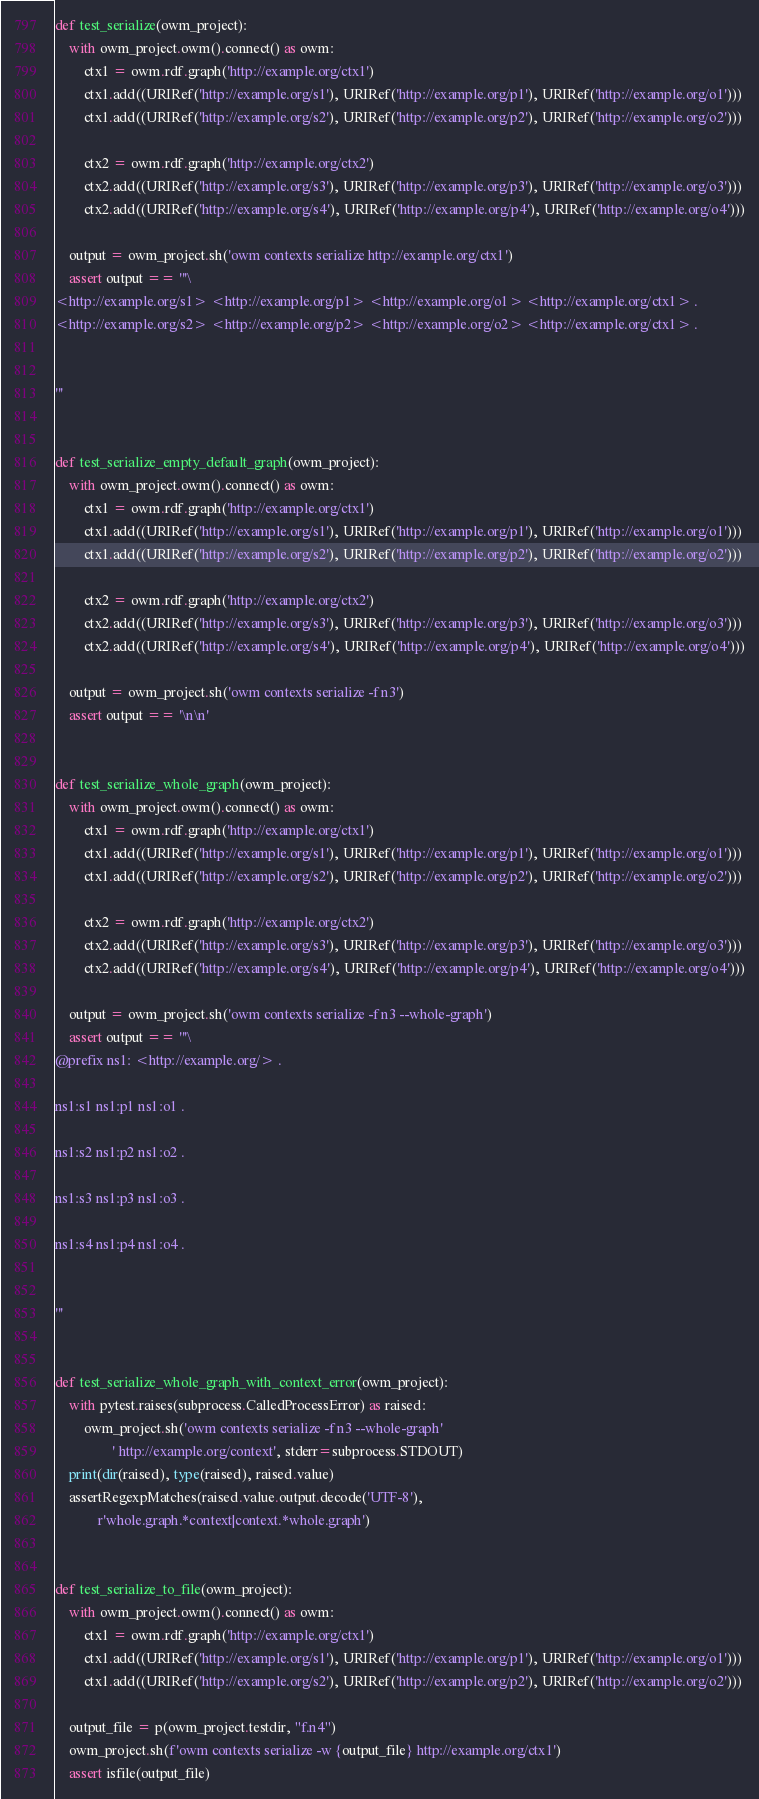Convert code to text. <code><loc_0><loc_0><loc_500><loc_500><_Python_>def test_serialize(owm_project):
    with owm_project.owm().connect() as owm:
        ctx1 = owm.rdf.graph('http://example.org/ctx1')
        ctx1.add((URIRef('http://example.org/s1'), URIRef('http://example.org/p1'), URIRef('http://example.org/o1')))
        ctx1.add((URIRef('http://example.org/s2'), URIRef('http://example.org/p2'), URIRef('http://example.org/o2')))

        ctx2 = owm.rdf.graph('http://example.org/ctx2')
        ctx2.add((URIRef('http://example.org/s3'), URIRef('http://example.org/p3'), URIRef('http://example.org/o3')))
        ctx2.add((URIRef('http://example.org/s4'), URIRef('http://example.org/p4'), URIRef('http://example.org/o4')))

    output = owm_project.sh('owm contexts serialize http://example.org/ctx1')
    assert output == '''\
<http://example.org/s1> <http://example.org/p1> <http://example.org/o1> <http://example.org/ctx1> .
<http://example.org/s2> <http://example.org/p2> <http://example.org/o2> <http://example.org/ctx1> .


'''


def test_serialize_empty_default_graph(owm_project):
    with owm_project.owm().connect() as owm:
        ctx1 = owm.rdf.graph('http://example.org/ctx1')
        ctx1.add((URIRef('http://example.org/s1'), URIRef('http://example.org/p1'), URIRef('http://example.org/o1')))
        ctx1.add((URIRef('http://example.org/s2'), URIRef('http://example.org/p2'), URIRef('http://example.org/o2')))

        ctx2 = owm.rdf.graph('http://example.org/ctx2')
        ctx2.add((URIRef('http://example.org/s3'), URIRef('http://example.org/p3'), URIRef('http://example.org/o3')))
        ctx2.add((URIRef('http://example.org/s4'), URIRef('http://example.org/p4'), URIRef('http://example.org/o4')))

    output = owm_project.sh('owm contexts serialize -f n3')
    assert output == '\n\n'


def test_serialize_whole_graph(owm_project):
    with owm_project.owm().connect() as owm:
        ctx1 = owm.rdf.graph('http://example.org/ctx1')
        ctx1.add((URIRef('http://example.org/s1'), URIRef('http://example.org/p1'), URIRef('http://example.org/o1')))
        ctx1.add((URIRef('http://example.org/s2'), URIRef('http://example.org/p2'), URIRef('http://example.org/o2')))

        ctx2 = owm.rdf.graph('http://example.org/ctx2')
        ctx2.add((URIRef('http://example.org/s3'), URIRef('http://example.org/p3'), URIRef('http://example.org/o3')))
        ctx2.add((URIRef('http://example.org/s4'), URIRef('http://example.org/p4'), URIRef('http://example.org/o4')))

    output = owm_project.sh('owm contexts serialize -f n3 --whole-graph')
    assert output == '''\
@prefix ns1: <http://example.org/> .

ns1:s1 ns1:p1 ns1:o1 .

ns1:s2 ns1:p2 ns1:o2 .

ns1:s3 ns1:p3 ns1:o3 .

ns1:s4 ns1:p4 ns1:o4 .


'''


def test_serialize_whole_graph_with_context_error(owm_project):
    with pytest.raises(subprocess.CalledProcessError) as raised:
        owm_project.sh('owm contexts serialize -f n3 --whole-graph'
                ' http://example.org/context', stderr=subprocess.STDOUT)
    print(dir(raised), type(raised), raised.value)
    assertRegexpMatches(raised.value.output.decode('UTF-8'),
            r'whole.graph.*context|context.*whole.graph')


def test_serialize_to_file(owm_project):
    with owm_project.owm().connect() as owm:
        ctx1 = owm.rdf.graph('http://example.org/ctx1')
        ctx1.add((URIRef('http://example.org/s1'), URIRef('http://example.org/p1'), URIRef('http://example.org/o1')))
        ctx1.add((URIRef('http://example.org/s2'), URIRef('http://example.org/p2'), URIRef('http://example.org/o2')))

    output_file = p(owm_project.testdir, "f.n4")
    owm_project.sh(f'owm contexts serialize -w {output_file} http://example.org/ctx1')
    assert isfile(output_file)
</code> 